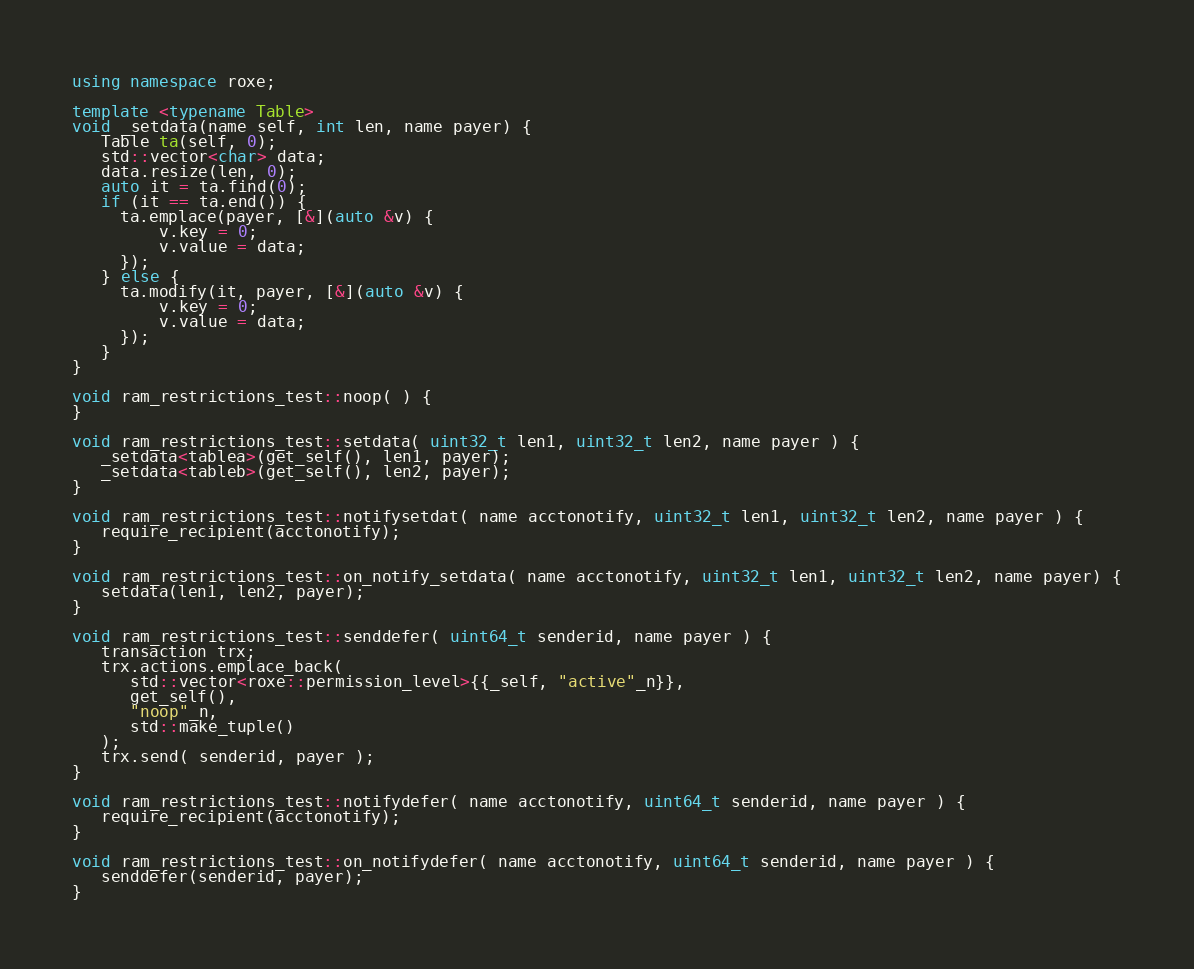<code> <loc_0><loc_0><loc_500><loc_500><_C++_>using namespace roxe;

template <typename Table>
void _setdata(name self, int len, name payer) {
   Table ta(self, 0);
   std::vector<char> data;
   data.resize(len, 0);
   auto it = ta.find(0);
   if (it == ta.end()) {
     ta.emplace(payer, [&](auto &v) {
         v.key = 0;
         v.value = data;
     });
   } else {
     ta.modify(it, payer, [&](auto &v) {
         v.key = 0;
         v.value = data;
     });
   }
}

void ram_restrictions_test::noop( ) {
}

void ram_restrictions_test::setdata( uint32_t len1, uint32_t len2, name payer ) {
   _setdata<tablea>(get_self(), len1, payer);
   _setdata<tableb>(get_self(), len2, payer);
}

void ram_restrictions_test::notifysetdat( name acctonotify, uint32_t len1, uint32_t len2, name payer ) {
   require_recipient(acctonotify);
}

void ram_restrictions_test::on_notify_setdata( name acctonotify, uint32_t len1, uint32_t len2, name payer) {
   setdata(len1, len2, payer);
}

void ram_restrictions_test::senddefer( uint64_t senderid, name payer ) {
   transaction trx;
   trx.actions.emplace_back(
      std::vector<roxe::permission_level>{{_self, "active"_n}},
      get_self(),
      "noop"_n,
      std::make_tuple()
   );
   trx.send( senderid, payer );
}

void ram_restrictions_test::notifydefer( name acctonotify, uint64_t senderid, name payer ) {
   require_recipient(acctonotify);
}

void ram_restrictions_test::on_notifydefer( name acctonotify, uint64_t senderid, name payer ) {
   senddefer(senderid, payer);
}
</code> 